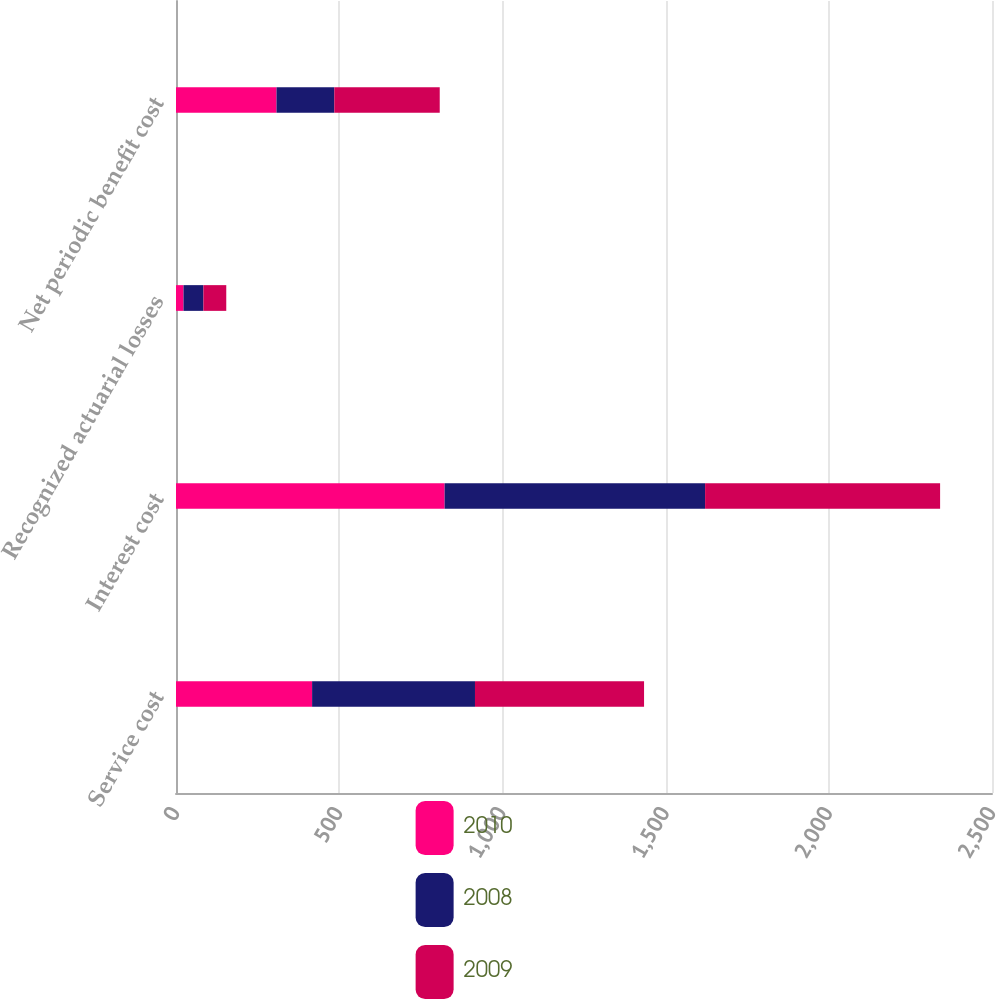Convert chart to OTSL. <chart><loc_0><loc_0><loc_500><loc_500><stacked_bar_chart><ecel><fcel>Service cost<fcel>Interest cost<fcel>Recognized actuarial losses<fcel>Net periodic benefit cost<nl><fcel>2010<fcel>417<fcel>823<fcel>23<fcel>308<nl><fcel>2008<fcel>499<fcel>798<fcel>61<fcel>177<nl><fcel>2009<fcel>518<fcel>720<fcel>70<fcel>323<nl></chart> 